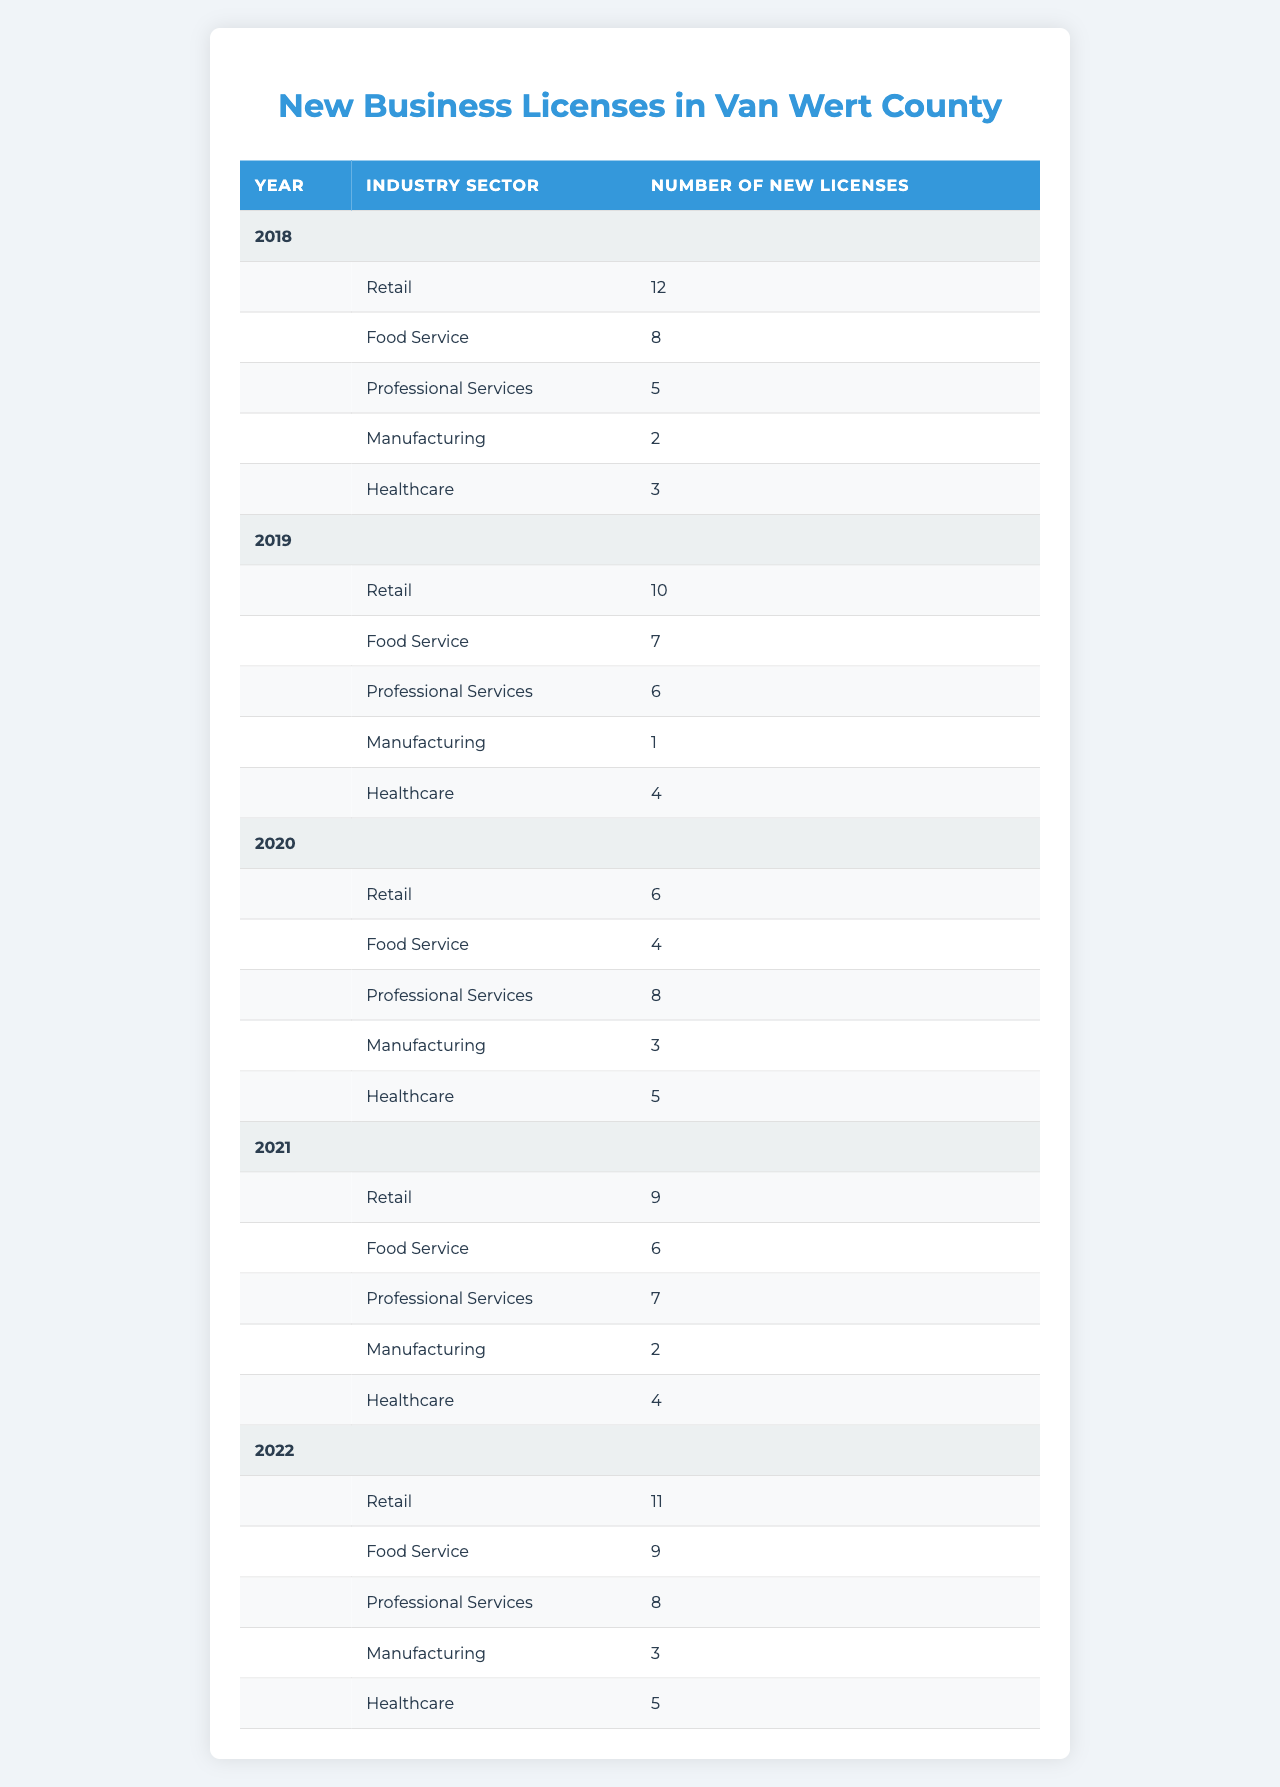What was the total number of new business licenses issued in 2020? In the year 2020, the table shows there were 6 retail licenses, 4 food service licenses, 8 professional services licenses, 3 manufacturing licenses, and 5 healthcare licenses. Adding these gives a total of 6 + 4 + 8 + 3 + 5 = 26 licenses.
Answer: 26 Which industry sector had the highest number of new licenses issued in 2019? In 2019, the table indicates that there were 10 retail licenses, 7 food service licenses, 6 professional services licenses, 1 manufacturing license, and 4 healthcare licenses. The highest number is from the retail sector with 10 licenses.
Answer: Retail How many new licenses were issued across all sectors in 2021? For 2021, the table shows 9 retail, 6 food service, 7 professional services, 2 manufacturing, and 4 healthcare licenses. Summing these gives 9 + 6 + 7 + 2 + 4 = 28 licenses in total for that year.
Answer: 28 Was there an increase in the number of healthcare licenses issued from 2018 to 2022? In 2018, there were 3 healthcare licenses issued, and in 2022, there were 5 licenses. Since 5 is greater than 3, there was indeed an increase.
Answer: Yes What is the average number of new retail licenses issued over the 5 years? The retail licenses issued were 12 (2018), 10 (2019), 6 (2020), 9 (2021), and 11 (2022). The average is calculated by finding the sum: 12 + 10 + 6 + 9 + 11 = 48, and then dividing by 5, giving 48 / 5 = 9.6.
Answer: 9.6 Which year had the lowest number of new manufacturing licenses issued? Reviewing the table, the number of new manufacturing licenses for each year is: 2 in 2018, 1 in 2019, 3 in 2020, 2 in 2021, and 3 in 2022. The lowest count is 1 in 2019.
Answer: 2019 What was the total number of new licenses in 2018, and how does it compare to 2022? In 2018, the new licenses totaled 12 (retail) + 8 (food service) + 5 (professional services) + 2 (manufacturing) + 3 (healthcare) = 30 licenses. In 2022, the total was 11 + 9 + 8 + 3 + 5 = 36 licenses. Since 36 is greater than 30, there was an increase.
Answer: 30; Increased Is the number of new food service licenses issued in 2020 greater than the sum of new healthcare and professional services licenses issued in the same year? In 2020, there were 4 food service licenses. The sum of healthcare (5) and professional services (8) licenses that year is 4 + 5 = 13. Since 4 is not greater than 13, it is false.
Answer: No How many more professional services licenses were issued in 2020 compared to 2019? In 2020, there were 8 professional services licenses issued and 6 in 2019. The difference is 8 - 6 = 2 licenses more in 2020 compared to 2019.
Answer: 2 